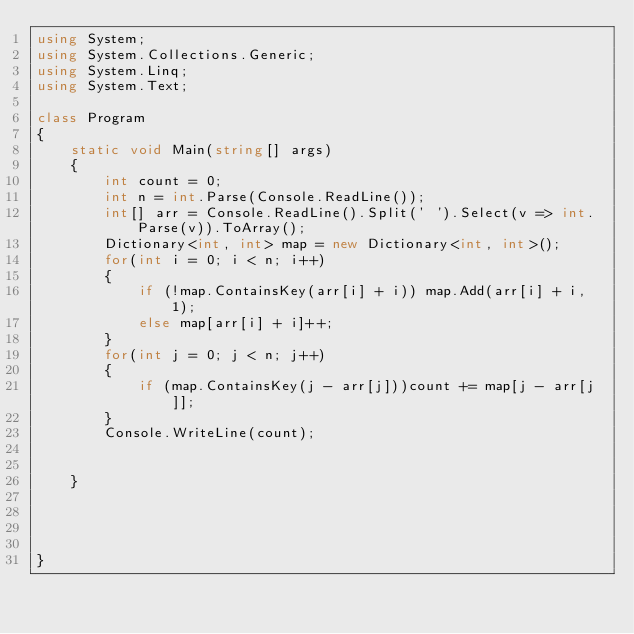Convert code to text. <code><loc_0><loc_0><loc_500><loc_500><_C#_>using System;
using System.Collections.Generic;
using System.Linq;
using System.Text;

class Program
{
    static void Main(string[] args)
    {
        int count = 0;
        int n = int.Parse(Console.ReadLine());
        int[] arr = Console.ReadLine().Split(' ').Select(v => int.Parse(v)).ToArray();
        Dictionary<int, int> map = new Dictionary<int, int>();
        for(int i = 0; i < n; i++)
        {
            if (!map.ContainsKey(arr[i] + i)) map.Add(arr[i] + i, 1);
            else map[arr[i] + i]++;
        }
        for(int j = 0; j < n; j++)
        {
            if (map.ContainsKey(j - arr[j]))count += map[j - arr[j]];
        }
        Console.WriteLine(count);
        

    }




}



</code> 